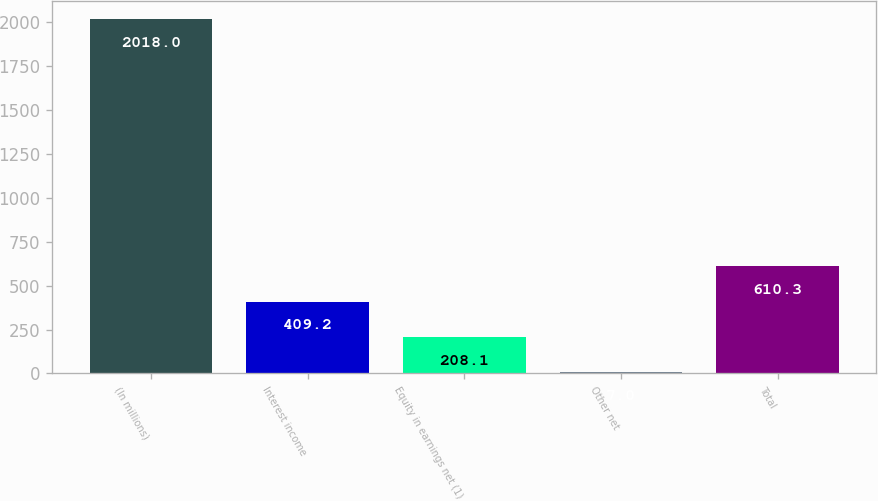Convert chart to OTSL. <chart><loc_0><loc_0><loc_500><loc_500><bar_chart><fcel>(In millions)<fcel>Interest income<fcel>Equity in earnings net (1)<fcel>Other net<fcel>Total<nl><fcel>2018<fcel>409.2<fcel>208.1<fcel>7<fcel>610.3<nl></chart> 